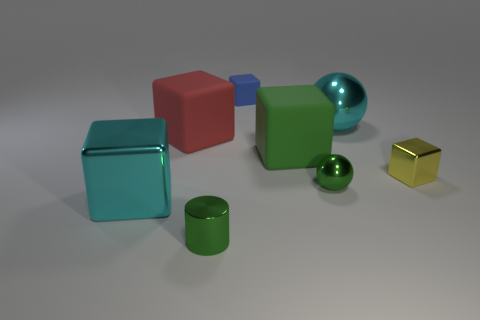Do the yellow shiny block and the red rubber cube have the same size?
Ensure brevity in your answer.  No. How many rubber objects are in front of the big green matte thing?
Give a very brief answer. 0. Are there the same number of large metallic objects to the left of the big cyan block and tiny green cylinders that are behind the blue block?
Your response must be concise. Yes. Is the shape of the large cyan shiny thing that is in front of the yellow object the same as  the large red thing?
Provide a short and direct response. Yes. Is there any other thing that is the same material as the large cyan sphere?
Ensure brevity in your answer.  Yes. Do the cyan shiny cube and the shiny sphere behind the tiny green ball have the same size?
Make the answer very short. Yes. What number of other things are the same color as the small cylinder?
Keep it short and to the point. 2. There is a small yellow object; are there any tiny green metallic spheres in front of it?
Offer a very short reply. Yes. What number of objects are large shiny objects or matte cubes behind the cyan sphere?
Offer a very short reply. 3. There is a yellow cube right of the big green thing; is there a large cyan shiny thing that is to the right of it?
Your answer should be very brief. No. 